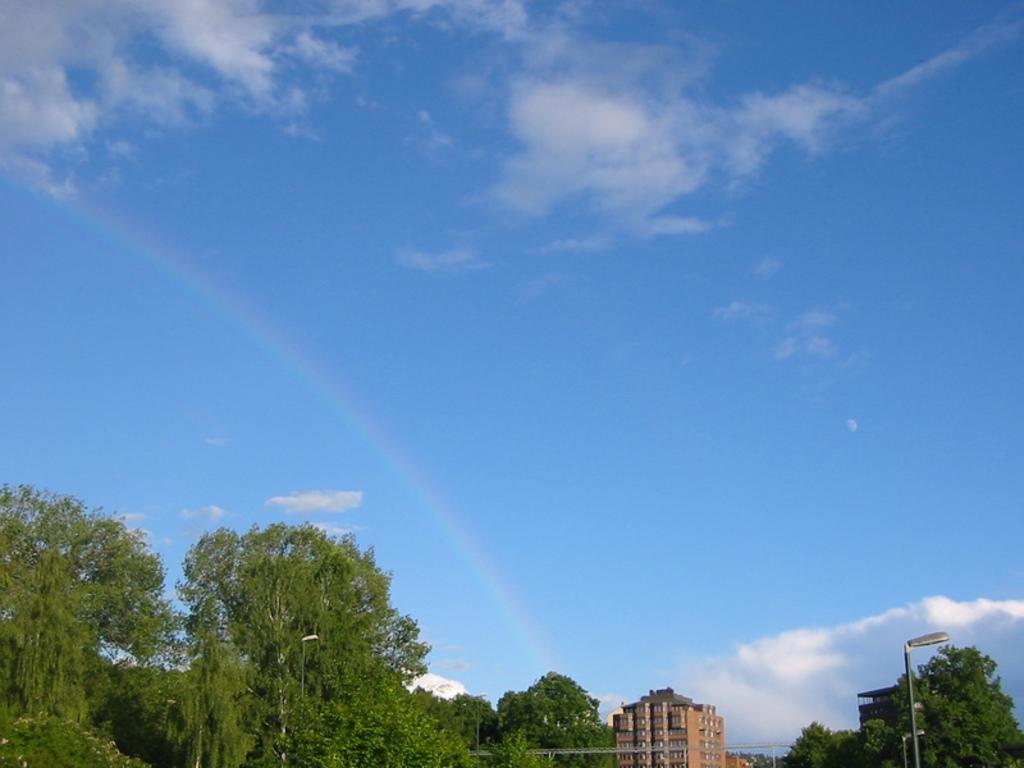What type of natural elements can be seen in the image? There are trees in the image. What type of man-made structures are present in the image? There are street lamps and buildings in the image. What is visible in the background of the image? The sky is visible in the image. What can be observed in the sky? Clouds are present in the sky. Can you tell me how many goats are standing on top of the buildings in the image? There are no goats present in the image; it features trees, street lamps, buildings, and clouds in the sky. What type of error can be seen in the image? There is no error present in the image; it is a clear and accurate representation of the scene. 